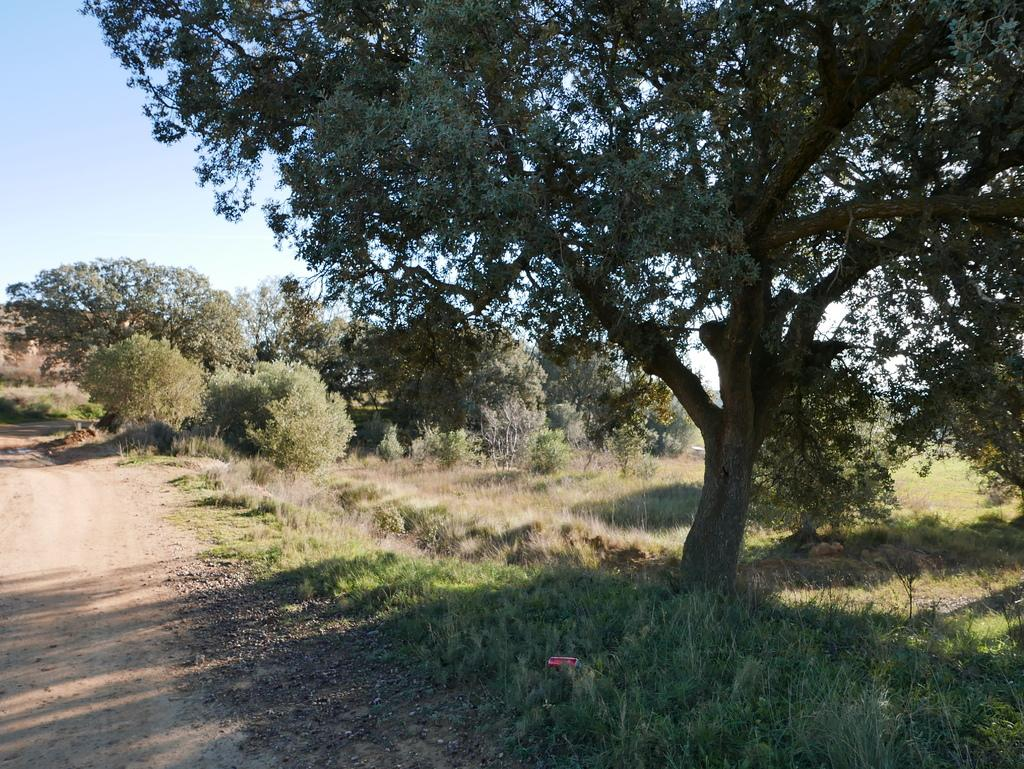What type of vegetation is present on the ground in the image? There is grass on the ground in the image. What can be seen in the distance behind the grass? There are trees in the background of the image. What else is visible in the background of the image? The sky is visible in the background of the image. Reasoning: Let' Let's think step by step in order to produce the conversation. We start by identifying the main subject on the ground, which is the grass. Then, we expand the conversation to include the background elements, such as the trees and the sky. Each question is designed to elicit a specific detail about the image that is known from the provided facts. Absurd Question/Answer: What type of drink is being pushed by the month in the image? There is no drink or month present in the image; it only features grass, trees, and the sky. What month is pushing the drink in the image? There is no month or drink present in the image; it only features grass, trees, and the sky. 